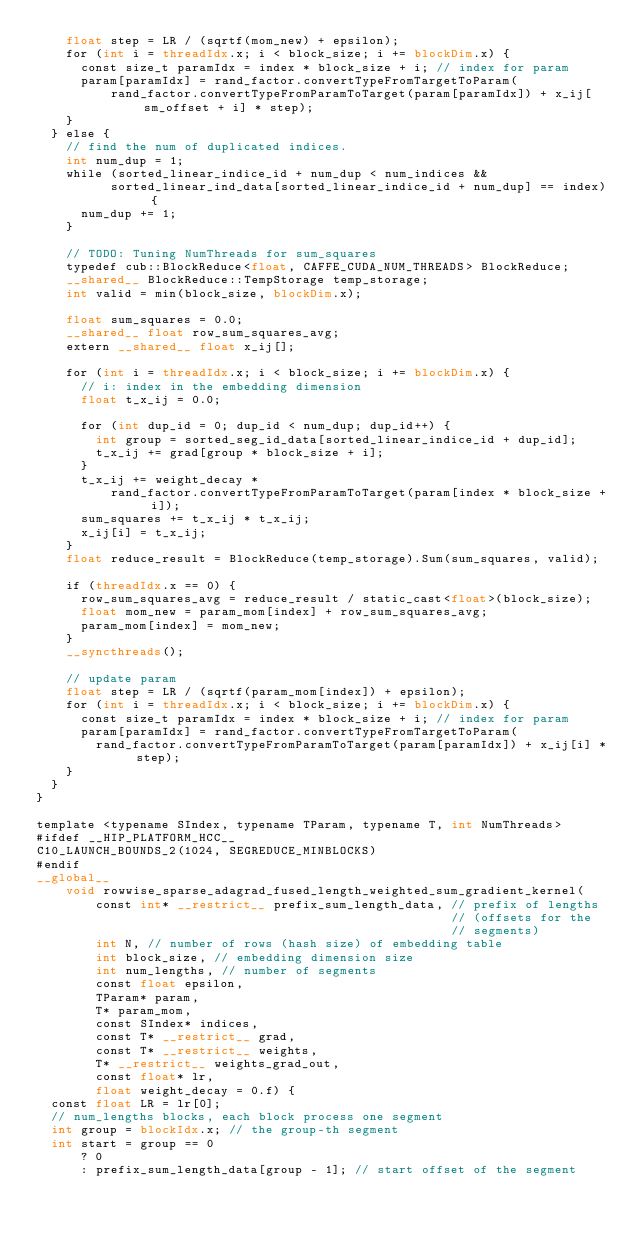<code> <loc_0><loc_0><loc_500><loc_500><_Cuda_>    float step = LR / (sqrtf(mom_new) + epsilon);
    for (int i = threadIdx.x; i < block_size; i += blockDim.x) {
      const size_t paramIdx = index * block_size + i; // index for param
      param[paramIdx] = rand_factor.convertTypeFromTargetToParam(
          rand_factor.convertTypeFromParamToTarget(param[paramIdx]) + x_ij[sm_offset + i] * step);
    }
  } else {
    // find the num of duplicated indices.
    int num_dup = 1;
    while (sorted_linear_indice_id + num_dup < num_indices &&
          sorted_linear_ind_data[sorted_linear_indice_id + num_dup] == index) {
      num_dup += 1;
    }

    // TODO: Tuning NumThreads for sum_squares
    typedef cub::BlockReduce<float, CAFFE_CUDA_NUM_THREADS> BlockReduce;
    __shared__ BlockReduce::TempStorage temp_storage;
    int valid = min(block_size, blockDim.x);

    float sum_squares = 0.0;
    __shared__ float row_sum_squares_avg;
    extern __shared__ float x_ij[];

    for (int i = threadIdx.x; i < block_size; i += blockDim.x) {
      // i: index in the embedding dimension
      float t_x_ij = 0.0;

      for (int dup_id = 0; dup_id < num_dup; dup_id++) {
        int group = sorted_seg_id_data[sorted_linear_indice_id + dup_id];
        t_x_ij += grad[group * block_size + i];
      }
      t_x_ij += weight_decay *
          rand_factor.convertTypeFromParamToTarget(param[index * block_size + i]);
      sum_squares += t_x_ij * t_x_ij;
      x_ij[i] = t_x_ij;
    }
    float reduce_result = BlockReduce(temp_storage).Sum(sum_squares, valid);

    if (threadIdx.x == 0) {
      row_sum_squares_avg = reduce_result / static_cast<float>(block_size);
      float mom_new = param_mom[index] + row_sum_squares_avg;
      param_mom[index] = mom_new;
    }
    __syncthreads();

    // update param
    float step = LR / (sqrtf(param_mom[index]) + epsilon);
    for (int i = threadIdx.x; i < block_size; i += blockDim.x) {
      const size_t paramIdx = index * block_size + i; // index for param
      param[paramIdx] = rand_factor.convertTypeFromTargetToParam(
        rand_factor.convertTypeFromParamToTarget(param[paramIdx]) + x_ij[i] * step);
    }
  }
}

template <typename SIndex, typename TParam, typename T, int NumThreads>
#ifdef __HIP_PLATFORM_HCC__
C10_LAUNCH_BOUNDS_2(1024, SEGREDUCE_MINBLOCKS)
#endif
__global__
    void rowwise_sparse_adagrad_fused_length_weighted_sum_gradient_kernel(
        const int* __restrict__ prefix_sum_length_data, // prefix of lengths
                                                        // (offsets for the
                                                        // segments)
        int N, // number of rows (hash size) of embedding table
        int block_size, // embedding dimension size
        int num_lengths, // number of segments
        const float epsilon,
        TParam* param,
        T* param_mom,
        const SIndex* indices,
        const T* __restrict__ grad,
        const T* __restrict__ weights,
        T* __restrict__ weights_grad_out,
        const float* lr,
        float weight_decay = 0.f) {
  const float LR = lr[0];
  // num_lengths blocks, each block process one segment
  int group = blockIdx.x; // the group-th segment
  int start = group == 0
      ? 0
      : prefix_sum_length_data[group - 1]; // start offset of the segment</code> 